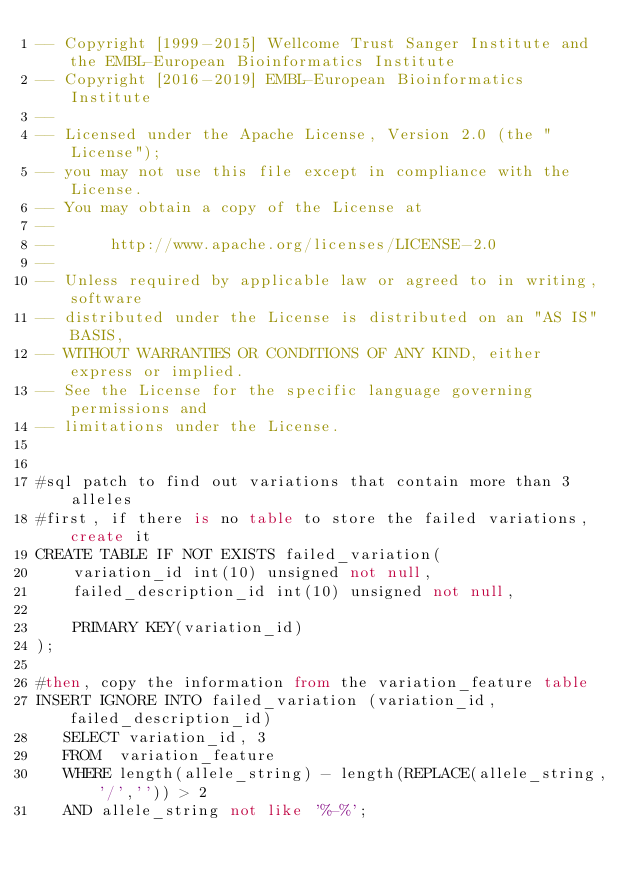Convert code to text. <code><loc_0><loc_0><loc_500><loc_500><_SQL_>-- Copyright [1999-2015] Wellcome Trust Sanger Institute and the EMBL-European Bioinformatics Institute
-- Copyright [2016-2019] EMBL-European Bioinformatics Institute
-- 
-- Licensed under the Apache License, Version 2.0 (the "License");
-- you may not use this file except in compliance with the License.
-- You may obtain a copy of the License at
-- 
--      http://www.apache.org/licenses/LICENSE-2.0
-- 
-- Unless required by applicable law or agreed to in writing, software
-- distributed under the License is distributed on an "AS IS" BASIS,
-- WITHOUT WARRANTIES OR CONDITIONS OF ANY KIND, either express or implied.
-- See the License for the specific language governing permissions and
-- limitations under the License.


#sql patch to find out variations that contain more than 3 alleles
#first, if there is no table to store the failed variations, create it
CREATE TABLE IF NOT EXISTS failed_variation(
    variation_id int(10) unsigned not null,
    failed_description_id int(10) unsigned not null,

    PRIMARY KEY(variation_id)
);

#then, copy the information from the variation_feature table
INSERT IGNORE INTO failed_variation (variation_id,failed_description_id) 
   SELECT variation_id, 3
   FROM  variation_feature
   WHERE length(allele_string) - length(REPLACE(allele_string,'/','')) > 2
   AND allele_string not like '%-%';
</code> 